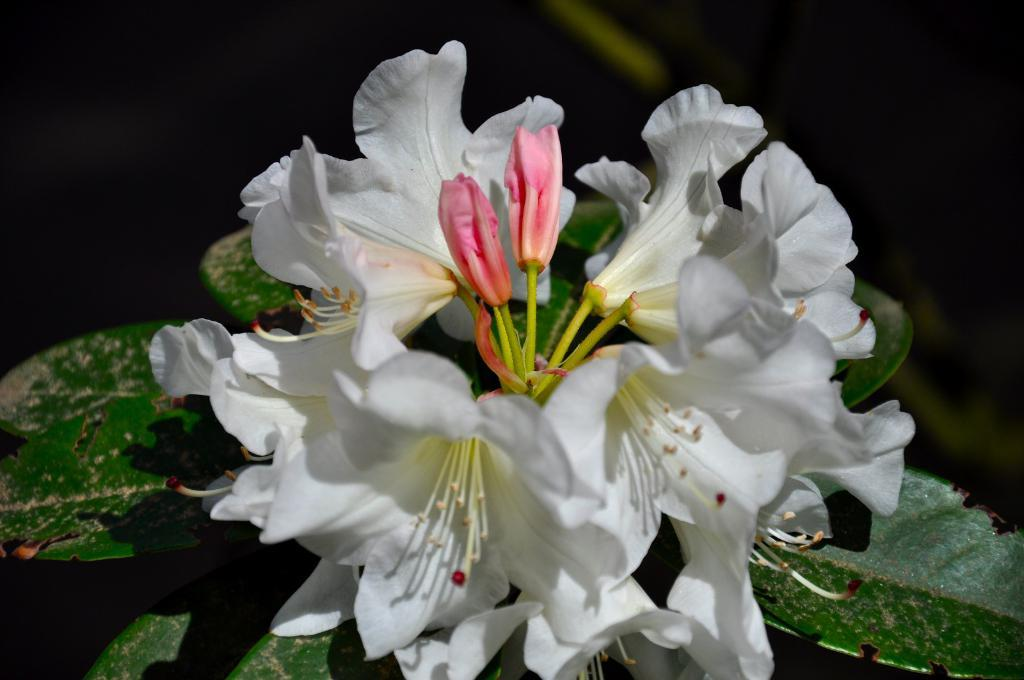What type of flora is present in the image? There are flowers in the image. What color are the flowers? The flowers are white in color. What other part of the plant can be seen in the image? There are green leaves in the image. How would you describe the background of the image? The background of the image is blurred. What type of meal is being prepared in the image? There is no meal preparation visible in the image; it features flowers and green leaves. Can you see any mist in the image? There is no mist present in the image. 